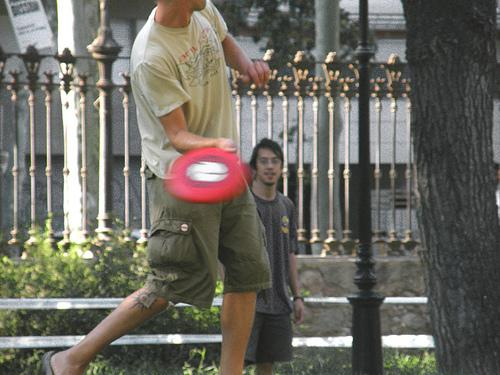What is tattooed on his right leg?

Choices:
A) gun
B) brain
C) heart
D) flag heart 